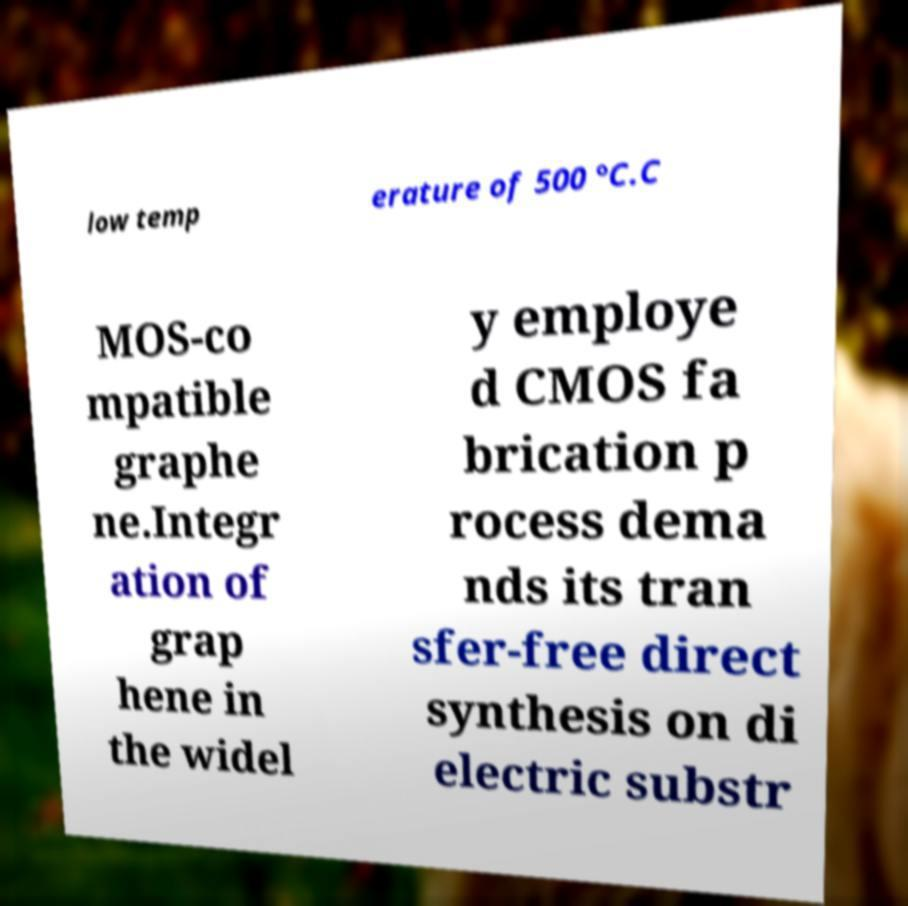Can you read and provide the text displayed in the image?This photo seems to have some interesting text. Can you extract and type it out for me? low temp erature of 500 °C.C MOS-co mpatible graphe ne.Integr ation of grap hene in the widel y employe d CMOS fa brication p rocess dema nds its tran sfer-free direct synthesis on di electric substr 